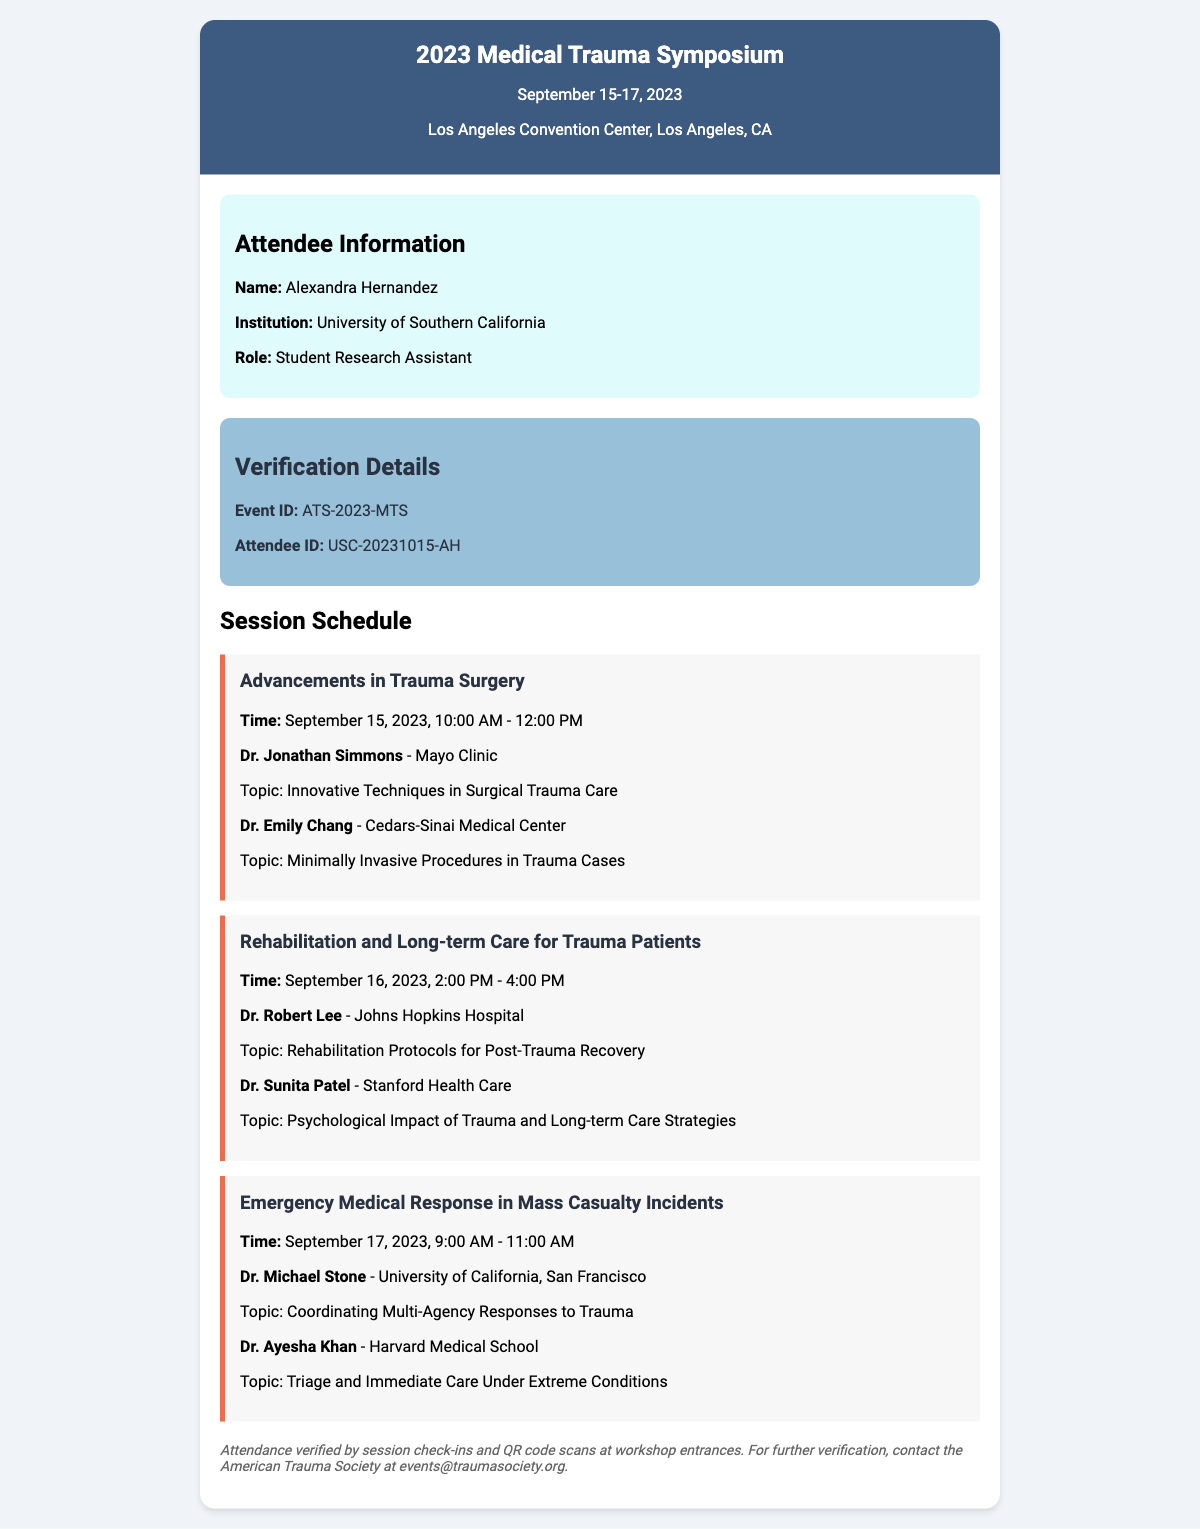What is the event's location? The event's location is specified in the document as "Los Angeles Convention Center, Los Angeles, CA."
Answer: Los Angeles Convention Center, Los Angeles, CA Who is the speaker for the session on "Advancements in Trauma Surgery"? The document lists two speakers for this session: Dr. Jonathan Simmons and Dr. Emily Chang.
Answer: Dr. Jonathan Simmons What is the time for the "Emergency Medical Response in Mass Casualty Incidents" session? The time for this session is noted in the document as "September 17, 2023, 9:00 AM - 11:00 AM."
Answer: September 17, 2023, 9:00 AM - 11:00 AM Which institution does Alexandra Hernandez represent? The document clearly states that Alexandra Hernandez represents the "University of Southern California."
Answer: University of Southern California What is the Event ID mentioned in the ticket? The Event ID is clearly listed in the verification details section of the document as "ATS-2023-MTS."
Answer: ATS-2023-MTS Which topic is covered by Dr. Michael Stone? The document specifies that Dr. Michael Stone covers the topic "Coordinating Multi-Agency Responses to Trauma."
Answer: Coordinating Multi-Agency Responses to Trauma What are the dates for the Medical Trauma Symposium? The event dates are mentioned as "September 15-17, 2023."
Answer: September 15-17, 2023 What type of event is this document verifying attendance for? The document verifies attendance for a symposium focused on trauma medicine.
Answer: symposium 